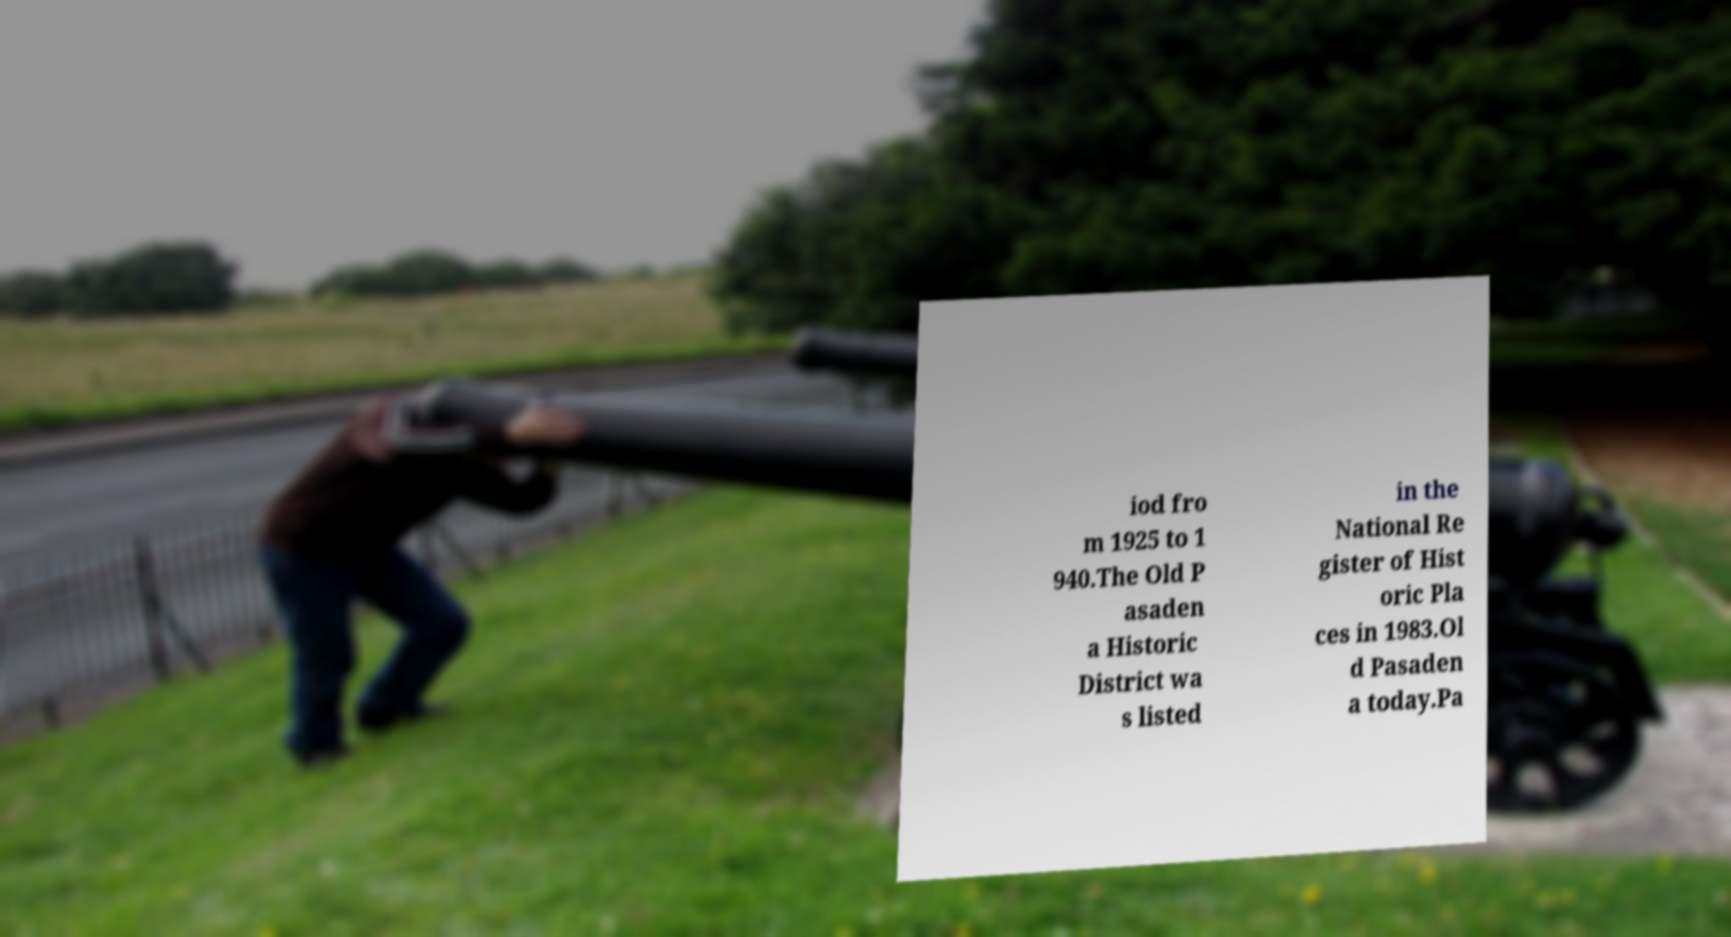What messages or text are displayed in this image? I need them in a readable, typed format. iod fro m 1925 to 1 940.The Old P asaden a Historic District wa s listed in the National Re gister of Hist oric Pla ces in 1983.Ol d Pasaden a today.Pa 